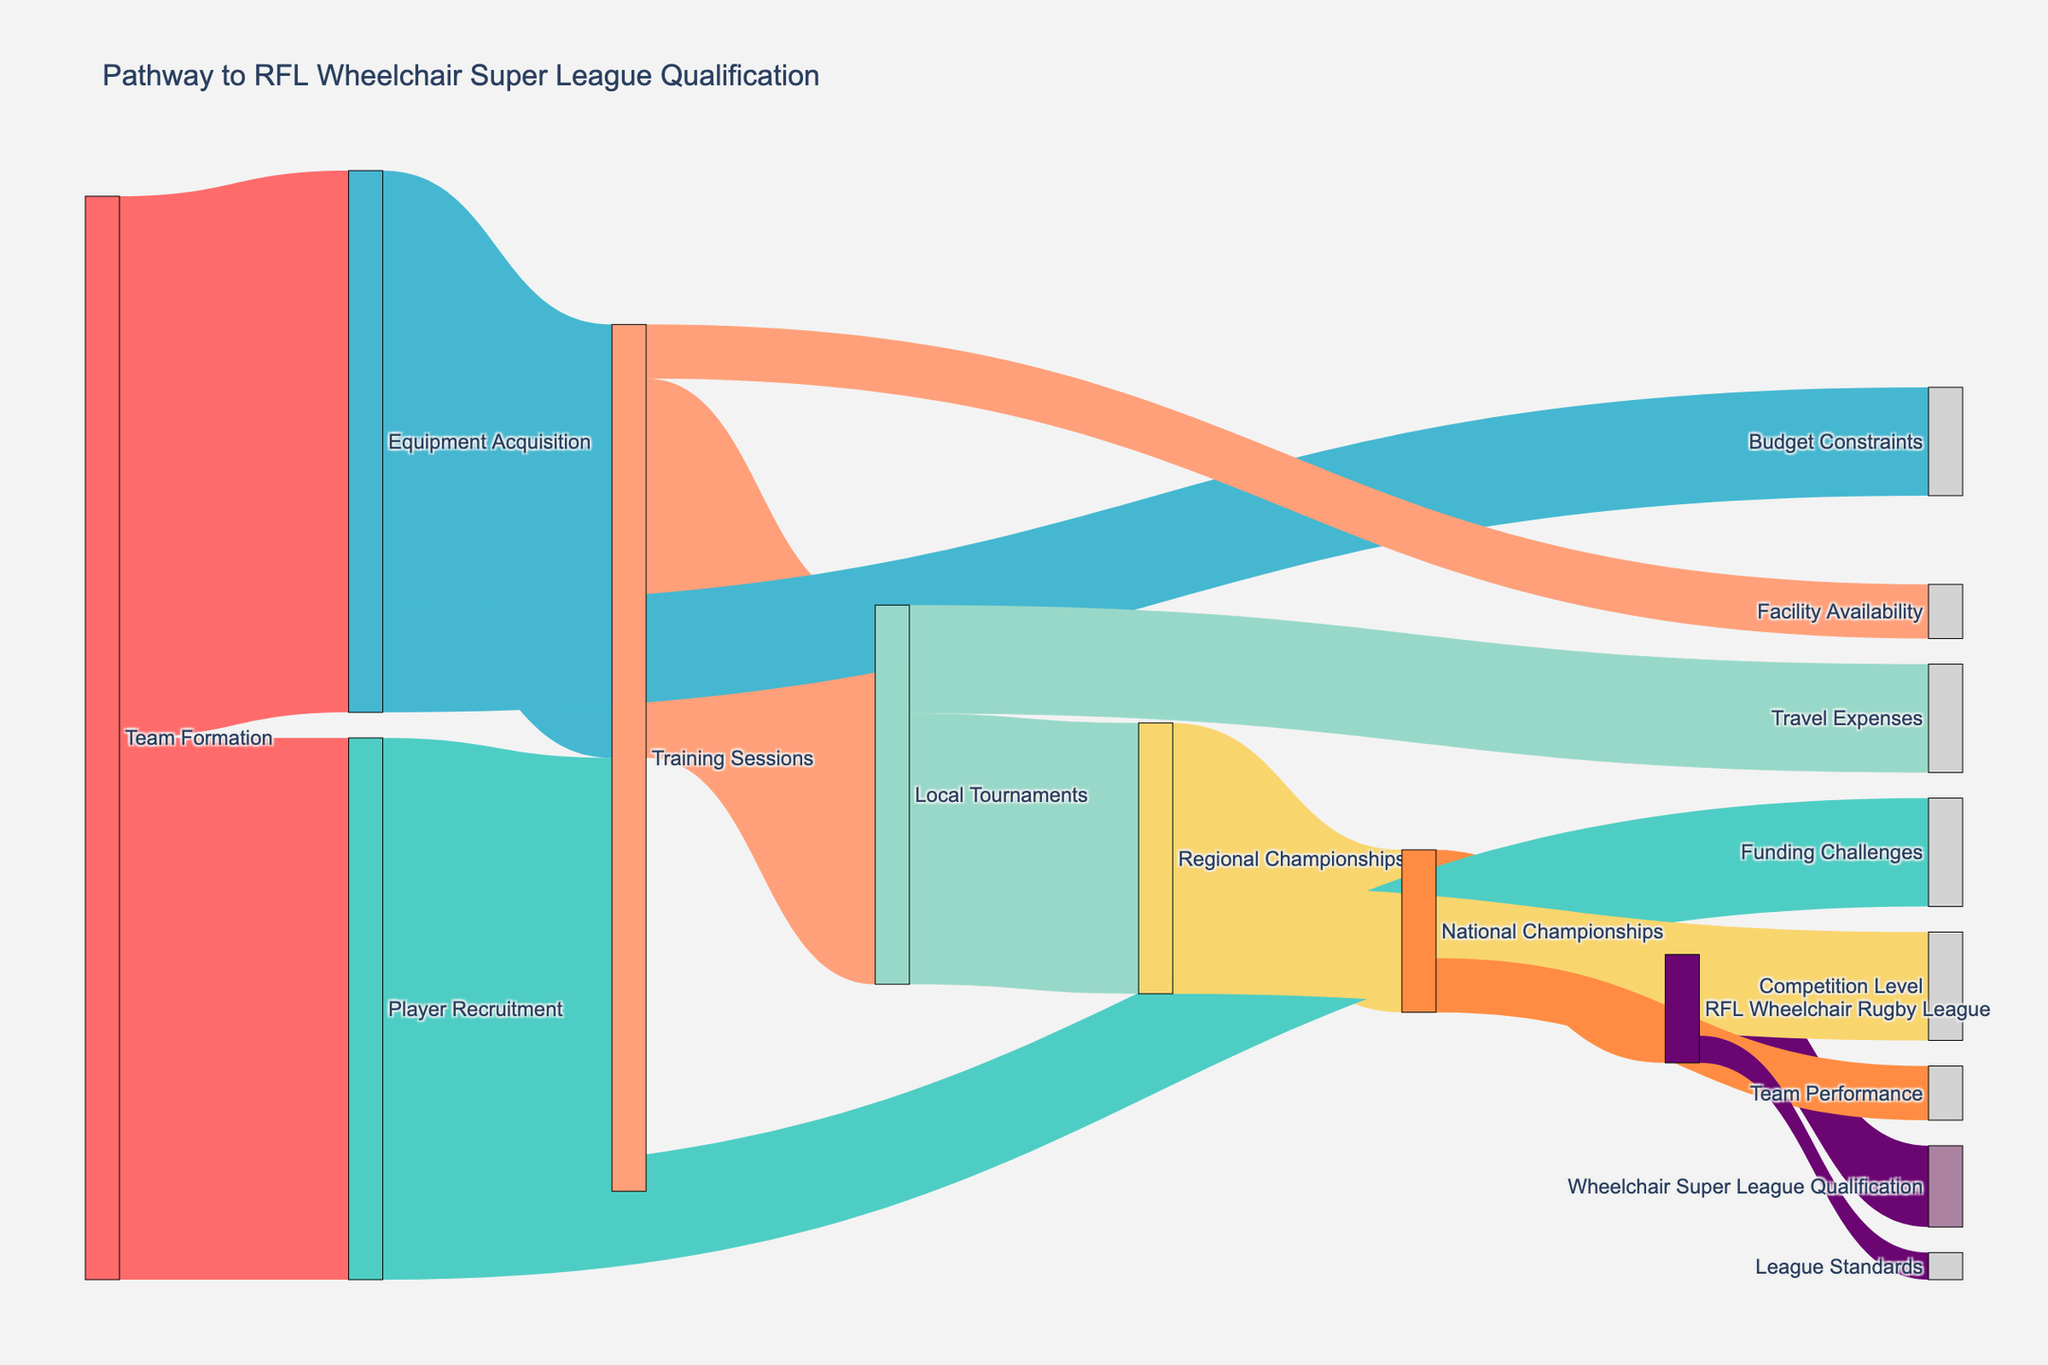How many stages are there in the pathway to Wheelchair Super League qualification? Count the unique stages in the Sankey diagram: Team Formation, Player Recruitment, Equipment Acquisition, Training Sessions, Local Tournaments, Regional Championships, National Championships, RFL Wheelchair Rugby League, Wheelchair Super League Qualification.
Answer: 9 What is the initial stage in the pathway? Identify the first node on the left of the Sankey diagram.
Answer: Team Formation How many potential obstacles are identified? Count the unique obstacles in the diagram: Funding Challenges, Budget Constraints, Facility Availability, Travel Expenses, Competition Level, Team Performance, League Standards.
Answer: 7 Which stage faces the highest number of potential obstacles? Look for the stage with the most connections to obstacles: Training Sessions has 1; Player Recruitment has 1; Equipment Acquisition has 1; Local Tournaments have 1; Regional Championships have 1; National Championships have 1; RFL Wheelchair Rugby League has 1; so they all have equal counts.
Answer: None/multiple stages What percentage of teams from National Championships qualify for the Wheelchair Super League? Compare the values flowing into 'RFL Wheelchair Rugby League' (20) and ‘National Championships’ (30). Calculate percentage: (20/30) * 100 = 66.67%
Answer: 67% Which stage directly contributes the most to Training Sessions? Look at the values going into 'Training Sessions': Player Recruitment (80), Equipment Acquisition (80). Both are equal.
Answer: Player Recruitment and Equipment Acquisition equally What is the value flow from Regional Championships to National Championships? Identify the link and read its value on the Sankey diagram.
Answer: 30 Is the value flow from Travel Expenses higher or lower than Budget Constraints? Compare the values for links related to Travel Expenses (20) and Budget Constraints (20). They are equal.
Answer: Equal By how much does the value decrease from RFL Wheelchair Rugby League to Wheelchair Super League Qualification? Subtract the value flowing into 'Wheelchair Super League Qualification' (15) from the value at 'RFL Wheelchair Rugby League' (20): 20 - 15 = 5
Answer: 5 Among the stages, which one has the lowest value transitioning to the next stage in the qualification pathway? Compare the values at each transition: Local Tournaments (70), Regional Championships (50), National Championships (30), RFL Wheelchair Rugby League (20), Wheelchair Super League Qualification (15).
Answer: Wheelchair Super League Qualification 